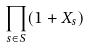<formula> <loc_0><loc_0><loc_500><loc_500>\prod _ { s \in S } ( 1 + X _ { s } )</formula> 